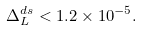<formula> <loc_0><loc_0><loc_500><loc_500>\Delta _ { L } ^ { d s } < 1 . 2 \times 1 0 ^ { - 5 } .</formula> 